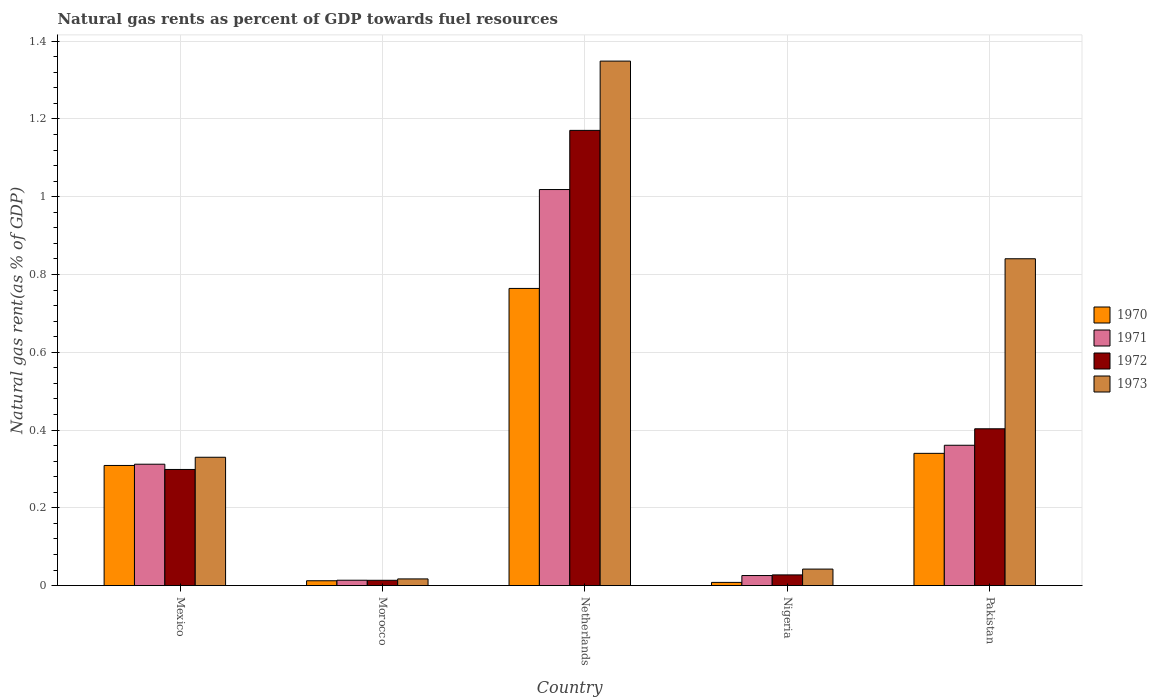How many different coloured bars are there?
Your answer should be very brief. 4. How many groups of bars are there?
Provide a short and direct response. 5. Are the number of bars per tick equal to the number of legend labels?
Make the answer very short. Yes. Are the number of bars on each tick of the X-axis equal?
Keep it short and to the point. Yes. How many bars are there on the 3rd tick from the left?
Your answer should be very brief. 4. How many bars are there on the 4th tick from the right?
Your answer should be compact. 4. What is the label of the 2nd group of bars from the left?
Make the answer very short. Morocco. In how many cases, is the number of bars for a given country not equal to the number of legend labels?
Ensure brevity in your answer.  0. What is the natural gas rent in 1970 in Morocco?
Offer a very short reply. 0.01. Across all countries, what is the maximum natural gas rent in 1971?
Keep it short and to the point. 1.02. Across all countries, what is the minimum natural gas rent in 1972?
Your answer should be very brief. 0.01. In which country was the natural gas rent in 1971 maximum?
Make the answer very short. Netherlands. In which country was the natural gas rent in 1970 minimum?
Provide a succinct answer. Nigeria. What is the total natural gas rent in 1970 in the graph?
Offer a very short reply. 1.43. What is the difference between the natural gas rent in 1973 in Morocco and that in Nigeria?
Offer a very short reply. -0.03. What is the difference between the natural gas rent in 1973 in Netherlands and the natural gas rent in 1972 in Mexico?
Ensure brevity in your answer.  1.05. What is the average natural gas rent in 1970 per country?
Your response must be concise. 0.29. What is the difference between the natural gas rent of/in 1971 and natural gas rent of/in 1972 in Nigeria?
Make the answer very short. -0. What is the ratio of the natural gas rent in 1972 in Netherlands to that in Pakistan?
Your response must be concise. 2.9. Is the difference between the natural gas rent in 1971 in Mexico and Pakistan greater than the difference between the natural gas rent in 1972 in Mexico and Pakistan?
Ensure brevity in your answer.  Yes. What is the difference between the highest and the second highest natural gas rent in 1971?
Make the answer very short. -0.66. What is the difference between the highest and the lowest natural gas rent in 1972?
Ensure brevity in your answer.  1.16. Is the sum of the natural gas rent in 1971 in Mexico and Morocco greater than the maximum natural gas rent in 1972 across all countries?
Your answer should be very brief. No. What does the 3rd bar from the right in Netherlands represents?
Provide a short and direct response. 1971. Is it the case that in every country, the sum of the natural gas rent in 1970 and natural gas rent in 1971 is greater than the natural gas rent in 1972?
Give a very brief answer. Yes. How many countries are there in the graph?
Provide a short and direct response. 5. What is the difference between two consecutive major ticks on the Y-axis?
Keep it short and to the point. 0.2. Where does the legend appear in the graph?
Provide a short and direct response. Center right. How many legend labels are there?
Your answer should be very brief. 4. How are the legend labels stacked?
Ensure brevity in your answer.  Vertical. What is the title of the graph?
Provide a short and direct response. Natural gas rents as percent of GDP towards fuel resources. Does "1973" appear as one of the legend labels in the graph?
Give a very brief answer. Yes. What is the label or title of the Y-axis?
Offer a very short reply. Natural gas rent(as % of GDP). What is the Natural gas rent(as % of GDP) of 1970 in Mexico?
Your answer should be very brief. 0.31. What is the Natural gas rent(as % of GDP) of 1971 in Mexico?
Offer a terse response. 0.31. What is the Natural gas rent(as % of GDP) in 1972 in Mexico?
Your answer should be compact. 0.3. What is the Natural gas rent(as % of GDP) of 1973 in Mexico?
Provide a succinct answer. 0.33. What is the Natural gas rent(as % of GDP) of 1970 in Morocco?
Provide a succinct answer. 0.01. What is the Natural gas rent(as % of GDP) of 1971 in Morocco?
Your answer should be compact. 0.01. What is the Natural gas rent(as % of GDP) of 1972 in Morocco?
Keep it short and to the point. 0.01. What is the Natural gas rent(as % of GDP) of 1973 in Morocco?
Keep it short and to the point. 0.02. What is the Natural gas rent(as % of GDP) in 1970 in Netherlands?
Offer a very short reply. 0.76. What is the Natural gas rent(as % of GDP) of 1971 in Netherlands?
Keep it short and to the point. 1.02. What is the Natural gas rent(as % of GDP) of 1972 in Netherlands?
Make the answer very short. 1.17. What is the Natural gas rent(as % of GDP) of 1973 in Netherlands?
Your answer should be compact. 1.35. What is the Natural gas rent(as % of GDP) of 1970 in Nigeria?
Keep it short and to the point. 0.01. What is the Natural gas rent(as % of GDP) of 1971 in Nigeria?
Ensure brevity in your answer.  0.03. What is the Natural gas rent(as % of GDP) in 1972 in Nigeria?
Give a very brief answer. 0.03. What is the Natural gas rent(as % of GDP) of 1973 in Nigeria?
Your response must be concise. 0.04. What is the Natural gas rent(as % of GDP) of 1970 in Pakistan?
Offer a terse response. 0.34. What is the Natural gas rent(as % of GDP) of 1971 in Pakistan?
Your answer should be compact. 0.36. What is the Natural gas rent(as % of GDP) in 1972 in Pakistan?
Provide a succinct answer. 0.4. What is the Natural gas rent(as % of GDP) of 1973 in Pakistan?
Keep it short and to the point. 0.84. Across all countries, what is the maximum Natural gas rent(as % of GDP) of 1970?
Ensure brevity in your answer.  0.76. Across all countries, what is the maximum Natural gas rent(as % of GDP) of 1971?
Your answer should be very brief. 1.02. Across all countries, what is the maximum Natural gas rent(as % of GDP) of 1972?
Provide a short and direct response. 1.17. Across all countries, what is the maximum Natural gas rent(as % of GDP) of 1973?
Keep it short and to the point. 1.35. Across all countries, what is the minimum Natural gas rent(as % of GDP) of 1970?
Make the answer very short. 0.01. Across all countries, what is the minimum Natural gas rent(as % of GDP) of 1971?
Your answer should be compact. 0.01. Across all countries, what is the minimum Natural gas rent(as % of GDP) in 1972?
Your answer should be very brief. 0.01. Across all countries, what is the minimum Natural gas rent(as % of GDP) of 1973?
Provide a succinct answer. 0.02. What is the total Natural gas rent(as % of GDP) in 1970 in the graph?
Provide a short and direct response. 1.43. What is the total Natural gas rent(as % of GDP) in 1971 in the graph?
Offer a very short reply. 1.73. What is the total Natural gas rent(as % of GDP) in 1972 in the graph?
Your answer should be very brief. 1.91. What is the total Natural gas rent(as % of GDP) in 1973 in the graph?
Your answer should be very brief. 2.58. What is the difference between the Natural gas rent(as % of GDP) of 1970 in Mexico and that in Morocco?
Provide a succinct answer. 0.3. What is the difference between the Natural gas rent(as % of GDP) of 1971 in Mexico and that in Morocco?
Your response must be concise. 0.3. What is the difference between the Natural gas rent(as % of GDP) of 1972 in Mexico and that in Morocco?
Your answer should be very brief. 0.28. What is the difference between the Natural gas rent(as % of GDP) of 1973 in Mexico and that in Morocco?
Your response must be concise. 0.31. What is the difference between the Natural gas rent(as % of GDP) of 1970 in Mexico and that in Netherlands?
Offer a very short reply. -0.46. What is the difference between the Natural gas rent(as % of GDP) of 1971 in Mexico and that in Netherlands?
Keep it short and to the point. -0.71. What is the difference between the Natural gas rent(as % of GDP) of 1972 in Mexico and that in Netherlands?
Give a very brief answer. -0.87. What is the difference between the Natural gas rent(as % of GDP) of 1973 in Mexico and that in Netherlands?
Provide a short and direct response. -1.02. What is the difference between the Natural gas rent(as % of GDP) of 1970 in Mexico and that in Nigeria?
Offer a very short reply. 0.3. What is the difference between the Natural gas rent(as % of GDP) in 1971 in Mexico and that in Nigeria?
Provide a succinct answer. 0.29. What is the difference between the Natural gas rent(as % of GDP) of 1972 in Mexico and that in Nigeria?
Give a very brief answer. 0.27. What is the difference between the Natural gas rent(as % of GDP) in 1973 in Mexico and that in Nigeria?
Keep it short and to the point. 0.29. What is the difference between the Natural gas rent(as % of GDP) in 1970 in Mexico and that in Pakistan?
Provide a succinct answer. -0.03. What is the difference between the Natural gas rent(as % of GDP) in 1971 in Mexico and that in Pakistan?
Provide a short and direct response. -0.05. What is the difference between the Natural gas rent(as % of GDP) of 1972 in Mexico and that in Pakistan?
Provide a succinct answer. -0.1. What is the difference between the Natural gas rent(as % of GDP) of 1973 in Mexico and that in Pakistan?
Provide a short and direct response. -0.51. What is the difference between the Natural gas rent(as % of GDP) in 1970 in Morocco and that in Netherlands?
Your answer should be very brief. -0.75. What is the difference between the Natural gas rent(as % of GDP) in 1971 in Morocco and that in Netherlands?
Keep it short and to the point. -1. What is the difference between the Natural gas rent(as % of GDP) in 1972 in Morocco and that in Netherlands?
Your response must be concise. -1.16. What is the difference between the Natural gas rent(as % of GDP) in 1973 in Morocco and that in Netherlands?
Offer a terse response. -1.33. What is the difference between the Natural gas rent(as % of GDP) of 1970 in Morocco and that in Nigeria?
Your response must be concise. 0. What is the difference between the Natural gas rent(as % of GDP) of 1971 in Morocco and that in Nigeria?
Make the answer very short. -0.01. What is the difference between the Natural gas rent(as % of GDP) of 1972 in Morocco and that in Nigeria?
Keep it short and to the point. -0.01. What is the difference between the Natural gas rent(as % of GDP) in 1973 in Morocco and that in Nigeria?
Offer a very short reply. -0.03. What is the difference between the Natural gas rent(as % of GDP) of 1970 in Morocco and that in Pakistan?
Provide a short and direct response. -0.33. What is the difference between the Natural gas rent(as % of GDP) in 1971 in Morocco and that in Pakistan?
Provide a succinct answer. -0.35. What is the difference between the Natural gas rent(as % of GDP) in 1972 in Morocco and that in Pakistan?
Keep it short and to the point. -0.39. What is the difference between the Natural gas rent(as % of GDP) in 1973 in Morocco and that in Pakistan?
Your answer should be very brief. -0.82. What is the difference between the Natural gas rent(as % of GDP) in 1970 in Netherlands and that in Nigeria?
Make the answer very short. 0.76. What is the difference between the Natural gas rent(as % of GDP) in 1971 in Netherlands and that in Nigeria?
Your answer should be compact. 0.99. What is the difference between the Natural gas rent(as % of GDP) in 1972 in Netherlands and that in Nigeria?
Ensure brevity in your answer.  1.14. What is the difference between the Natural gas rent(as % of GDP) in 1973 in Netherlands and that in Nigeria?
Give a very brief answer. 1.31. What is the difference between the Natural gas rent(as % of GDP) in 1970 in Netherlands and that in Pakistan?
Offer a terse response. 0.42. What is the difference between the Natural gas rent(as % of GDP) of 1971 in Netherlands and that in Pakistan?
Ensure brevity in your answer.  0.66. What is the difference between the Natural gas rent(as % of GDP) in 1972 in Netherlands and that in Pakistan?
Keep it short and to the point. 0.77. What is the difference between the Natural gas rent(as % of GDP) in 1973 in Netherlands and that in Pakistan?
Offer a terse response. 0.51. What is the difference between the Natural gas rent(as % of GDP) of 1970 in Nigeria and that in Pakistan?
Make the answer very short. -0.33. What is the difference between the Natural gas rent(as % of GDP) of 1971 in Nigeria and that in Pakistan?
Your answer should be compact. -0.34. What is the difference between the Natural gas rent(as % of GDP) in 1972 in Nigeria and that in Pakistan?
Give a very brief answer. -0.38. What is the difference between the Natural gas rent(as % of GDP) of 1973 in Nigeria and that in Pakistan?
Keep it short and to the point. -0.8. What is the difference between the Natural gas rent(as % of GDP) in 1970 in Mexico and the Natural gas rent(as % of GDP) in 1971 in Morocco?
Your answer should be very brief. 0.3. What is the difference between the Natural gas rent(as % of GDP) of 1970 in Mexico and the Natural gas rent(as % of GDP) of 1972 in Morocco?
Give a very brief answer. 0.3. What is the difference between the Natural gas rent(as % of GDP) of 1970 in Mexico and the Natural gas rent(as % of GDP) of 1973 in Morocco?
Provide a succinct answer. 0.29. What is the difference between the Natural gas rent(as % of GDP) in 1971 in Mexico and the Natural gas rent(as % of GDP) in 1972 in Morocco?
Your answer should be compact. 0.3. What is the difference between the Natural gas rent(as % of GDP) in 1971 in Mexico and the Natural gas rent(as % of GDP) in 1973 in Morocco?
Give a very brief answer. 0.29. What is the difference between the Natural gas rent(as % of GDP) in 1972 in Mexico and the Natural gas rent(as % of GDP) in 1973 in Morocco?
Keep it short and to the point. 0.28. What is the difference between the Natural gas rent(as % of GDP) in 1970 in Mexico and the Natural gas rent(as % of GDP) in 1971 in Netherlands?
Ensure brevity in your answer.  -0.71. What is the difference between the Natural gas rent(as % of GDP) in 1970 in Mexico and the Natural gas rent(as % of GDP) in 1972 in Netherlands?
Offer a terse response. -0.86. What is the difference between the Natural gas rent(as % of GDP) in 1970 in Mexico and the Natural gas rent(as % of GDP) in 1973 in Netherlands?
Ensure brevity in your answer.  -1.04. What is the difference between the Natural gas rent(as % of GDP) in 1971 in Mexico and the Natural gas rent(as % of GDP) in 1972 in Netherlands?
Make the answer very short. -0.86. What is the difference between the Natural gas rent(as % of GDP) of 1971 in Mexico and the Natural gas rent(as % of GDP) of 1973 in Netherlands?
Provide a short and direct response. -1.04. What is the difference between the Natural gas rent(as % of GDP) of 1972 in Mexico and the Natural gas rent(as % of GDP) of 1973 in Netherlands?
Give a very brief answer. -1.05. What is the difference between the Natural gas rent(as % of GDP) in 1970 in Mexico and the Natural gas rent(as % of GDP) in 1971 in Nigeria?
Provide a short and direct response. 0.28. What is the difference between the Natural gas rent(as % of GDP) in 1970 in Mexico and the Natural gas rent(as % of GDP) in 1972 in Nigeria?
Keep it short and to the point. 0.28. What is the difference between the Natural gas rent(as % of GDP) in 1970 in Mexico and the Natural gas rent(as % of GDP) in 1973 in Nigeria?
Your answer should be very brief. 0.27. What is the difference between the Natural gas rent(as % of GDP) of 1971 in Mexico and the Natural gas rent(as % of GDP) of 1972 in Nigeria?
Your answer should be compact. 0.28. What is the difference between the Natural gas rent(as % of GDP) of 1971 in Mexico and the Natural gas rent(as % of GDP) of 1973 in Nigeria?
Offer a very short reply. 0.27. What is the difference between the Natural gas rent(as % of GDP) in 1972 in Mexico and the Natural gas rent(as % of GDP) in 1973 in Nigeria?
Your answer should be compact. 0.26. What is the difference between the Natural gas rent(as % of GDP) of 1970 in Mexico and the Natural gas rent(as % of GDP) of 1971 in Pakistan?
Provide a succinct answer. -0.05. What is the difference between the Natural gas rent(as % of GDP) in 1970 in Mexico and the Natural gas rent(as % of GDP) in 1972 in Pakistan?
Your answer should be very brief. -0.09. What is the difference between the Natural gas rent(as % of GDP) of 1970 in Mexico and the Natural gas rent(as % of GDP) of 1973 in Pakistan?
Offer a terse response. -0.53. What is the difference between the Natural gas rent(as % of GDP) in 1971 in Mexico and the Natural gas rent(as % of GDP) in 1972 in Pakistan?
Make the answer very short. -0.09. What is the difference between the Natural gas rent(as % of GDP) of 1971 in Mexico and the Natural gas rent(as % of GDP) of 1973 in Pakistan?
Ensure brevity in your answer.  -0.53. What is the difference between the Natural gas rent(as % of GDP) of 1972 in Mexico and the Natural gas rent(as % of GDP) of 1973 in Pakistan?
Offer a terse response. -0.54. What is the difference between the Natural gas rent(as % of GDP) in 1970 in Morocco and the Natural gas rent(as % of GDP) in 1971 in Netherlands?
Your answer should be compact. -1.01. What is the difference between the Natural gas rent(as % of GDP) of 1970 in Morocco and the Natural gas rent(as % of GDP) of 1972 in Netherlands?
Your response must be concise. -1.16. What is the difference between the Natural gas rent(as % of GDP) in 1970 in Morocco and the Natural gas rent(as % of GDP) in 1973 in Netherlands?
Your answer should be compact. -1.34. What is the difference between the Natural gas rent(as % of GDP) of 1971 in Morocco and the Natural gas rent(as % of GDP) of 1972 in Netherlands?
Provide a short and direct response. -1.16. What is the difference between the Natural gas rent(as % of GDP) of 1971 in Morocco and the Natural gas rent(as % of GDP) of 1973 in Netherlands?
Your answer should be very brief. -1.33. What is the difference between the Natural gas rent(as % of GDP) in 1972 in Morocco and the Natural gas rent(as % of GDP) in 1973 in Netherlands?
Keep it short and to the point. -1.34. What is the difference between the Natural gas rent(as % of GDP) of 1970 in Morocco and the Natural gas rent(as % of GDP) of 1971 in Nigeria?
Your response must be concise. -0.01. What is the difference between the Natural gas rent(as % of GDP) in 1970 in Morocco and the Natural gas rent(as % of GDP) in 1972 in Nigeria?
Provide a short and direct response. -0.02. What is the difference between the Natural gas rent(as % of GDP) of 1970 in Morocco and the Natural gas rent(as % of GDP) of 1973 in Nigeria?
Ensure brevity in your answer.  -0.03. What is the difference between the Natural gas rent(as % of GDP) of 1971 in Morocco and the Natural gas rent(as % of GDP) of 1972 in Nigeria?
Give a very brief answer. -0.01. What is the difference between the Natural gas rent(as % of GDP) of 1971 in Morocco and the Natural gas rent(as % of GDP) of 1973 in Nigeria?
Offer a terse response. -0.03. What is the difference between the Natural gas rent(as % of GDP) in 1972 in Morocco and the Natural gas rent(as % of GDP) in 1973 in Nigeria?
Your response must be concise. -0.03. What is the difference between the Natural gas rent(as % of GDP) in 1970 in Morocco and the Natural gas rent(as % of GDP) in 1971 in Pakistan?
Give a very brief answer. -0.35. What is the difference between the Natural gas rent(as % of GDP) of 1970 in Morocco and the Natural gas rent(as % of GDP) of 1972 in Pakistan?
Offer a terse response. -0.39. What is the difference between the Natural gas rent(as % of GDP) in 1970 in Morocco and the Natural gas rent(as % of GDP) in 1973 in Pakistan?
Offer a terse response. -0.83. What is the difference between the Natural gas rent(as % of GDP) in 1971 in Morocco and the Natural gas rent(as % of GDP) in 1972 in Pakistan?
Your answer should be very brief. -0.39. What is the difference between the Natural gas rent(as % of GDP) of 1971 in Morocco and the Natural gas rent(as % of GDP) of 1973 in Pakistan?
Offer a very short reply. -0.83. What is the difference between the Natural gas rent(as % of GDP) of 1972 in Morocco and the Natural gas rent(as % of GDP) of 1973 in Pakistan?
Give a very brief answer. -0.83. What is the difference between the Natural gas rent(as % of GDP) in 1970 in Netherlands and the Natural gas rent(as % of GDP) in 1971 in Nigeria?
Give a very brief answer. 0.74. What is the difference between the Natural gas rent(as % of GDP) in 1970 in Netherlands and the Natural gas rent(as % of GDP) in 1972 in Nigeria?
Your response must be concise. 0.74. What is the difference between the Natural gas rent(as % of GDP) in 1970 in Netherlands and the Natural gas rent(as % of GDP) in 1973 in Nigeria?
Your response must be concise. 0.72. What is the difference between the Natural gas rent(as % of GDP) in 1971 in Netherlands and the Natural gas rent(as % of GDP) in 1972 in Nigeria?
Your response must be concise. 0.99. What is the difference between the Natural gas rent(as % of GDP) in 1971 in Netherlands and the Natural gas rent(as % of GDP) in 1973 in Nigeria?
Provide a short and direct response. 0.98. What is the difference between the Natural gas rent(as % of GDP) of 1972 in Netherlands and the Natural gas rent(as % of GDP) of 1973 in Nigeria?
Your response must be concise. 1.13. What is the difference between the Natural gas rent(as % of GDP) in 1970 in Netherlands and the Natural gas rent(as % of GDP) in 1971 in Pakistan?
Your answer should be very brief. 0.4. What is the difference between the Natural gas rent(as % of GDP) of 1970 in Netherlands and the Natural gas rent(as % of GDP) of 1972 in Pakistan?
Provide a short and direct response. 0.36. What is the difference between the Natural gas rent(as % of GDP) in 1970 in Netherlands and the Natural gas rent(as % of GDP) in 1973 in Pakistan?
Offer a very short reply. -0.08. What is the difference between the Natural gas rent(as % of GDP) of 1971 in Netherlands and the Natural gas rent(as % of GDP) of 1972 in Pakistan?
Offer a terse response. 0.62. What is the difference between the Natural gas rent(as % of GDP) in 1971 in Netherlands and the Natural gas rent(as % of GDP) in 1973 in Pakistan?
Offer a terse response. 0.18. What is the difference between the Natural gas rent(as % of GDP) in 1972 in Netherlands and the Natural gas rent(as % of GDP) in 1973 in Pakistan?
Make the answer very short. 0.33. What is the difference between the Natural gas rent(as % of GDP) of 1970 in Nigeria and the Natural gas rent(as % of GDP) of 1971 in Pakistan?
Give a very brief answer. -0.35. What is the difference between the Natural gas rent(as % of GDP) in 1970 in Nigeria and the Natural gas rent(as % of GDP) in 1972 in Pakistan?
Your response must be concise. -0.4. What is the difference between the Natural gas rent(as % of GDP) in 1970 in Nigeria and the Natural gas rent(as % of GDP) in 1973 in Pakistan?
Offer a very short reply. -0.83. What is the difference between the Natural gas rent(as % of GDP) of 1971 in Nigeria and the Natural gas rent(as % of GDP) of 1972 in Pakistan?
Keep it short and to the point. -0.38. What is the difference between the Natural gas rent(as % of GDP) of 1971 in Nigeria and the Natural gas rent(as % of GDP) of 1973 in Pakistan?
Provide a succinct answer. -0.81. What is the difference between the Natural gas rent(as % of GDP) of 1972 in Nigeria and the Natural gas rent(as % of GDP) of 1973 in Pakistan?
Keep it short and to the point. -0.81. What is the average Natural gas rent(as % of GDP) of 1970 per country?
Provide a short and direct response. 0.29. What is the average Natural gas rent(as % of GDP) of 1971 per country?
Make the answer very short. 0.35. What is the average Natural gas rent(as % of GDP) in 1972 per country?
Provide a succinct answer. 0.38. What is the average Natural gas rent(as % of GDP) in 1973 per country?
Give a very brief answer. 0.52. What is the difference between the Natural gas rent(as % of GDP) in 1970 and Natural gas rent(as % of GDP) in 1971 in Mexico?
Your answer should be very brief. -0. What is the difference between the Natural gas rent(as % of GDP) in 1970 and Natural gas rent(as % of GDP) in 1972 in Mexico?
Provide a succinct answer. 0.01. What is the difference between the Natural gas rent(as % of GDP) of 1970 and Natural gas rent(as % of GDP) of 1973 in Mexico?
Give a very brief answer. -0.02. What is the difference between the Natural gas rent(as % of GDP) in 1971 and Natural gas rent(as % of GDP) in 1972 in Mexico?
Your answer should be compact. 0.01. What is the difference between the Natural gas rent(as % of GDP) of 1971 and Natural gas rent(as % of GDP) of 1973 in Mexico?
Provide a succinct answer. -0.02. What is the difference between the Natural gas rent(as % of GDP) in 1972 and Natural gas rent(as % of GDP) in 1973 in Mexico?
Offer a very short reply. -0.03. What is the difference between the Natural gas rent(as % of GDP) in 1970 and Natural gas rent(as % of GDP) in 1971 in Morocco?
Your answer should be very brief. -0. What is the difference between the Natural gas rent(as % of GDP) in 1970 and Natural gas rent(as % of GDP) in 1972 in Morocco?
Provide a short and direct response. -0. What is the difference between the Natural gas rent(as % of GDP) of 1970 and Natural gas rent(as % of GDP) of 1973 in Morocco?
Your response must be concise. -0. What is the difference between the Natural gas rent(as % of GDP) of 1971 and Natural gas rent(as % of GDP) of 1973 in Morocco?
Your answer should be very brief. -0. What is the difference between the Natural gas rent(as % of GDP) in 1972 and Natural gas rent(as % of GDP) in 1973 in Morocco?
Offer a terse response. -0. What is the difference between the Natural gas rent(as % of GDP) in 1970 and Natural gas rent(as % of GDP) in 1971 in Netherlands?
Your response must be concise. -0.25. What is the difference between the Natural gas rent(as % of GDP) in 1970 and Natural gas rent(as % of GDP) in 1972 in Netherlands?
Make the answer very short. -0.41. What is the difference between the Natural gas rent(as % of GDP) of 1970 and Natural gas rent(as % of GDP) of 1973 in Netherlands?
Keep it short and to the point. -0.58. What is the difference between the Natural gas rent(as % of GDP) in 1971 and Natural gas rent(as % of GDP) in 1972 in Netherlands?
Offer a terse response. -0.15. What is the difference between the Natural gas rent(as % of GDP) of 1971 and Natural gas rent(as % of GDP) of 1973 in Netherlands?
Offer a terse response. -0.33. What is the difference between the Natural gas rent(as % of GDP) in 1972 and Natural gas rent(as % of GDP) in 1973 in Netherlands?
Make the answer very short. -0.18. What is the difference between the Natural gas rent(as % of GDP) of 1970 and Natural gas rent(as % of GDP) of 1971 in Nigeria?
Keep it short and to the point. -0.02. What is the difference between the Natural gas rent(as % of GDP) in 1970 and Natural gas rent(as % of GDP) in 1972 in Nigeria?
Provide a short and direct response. -0.02. What is the difference between the Natural gas rent(as % of GDP) of 1970 and Natural gas rent(as % of GDP) of 1973 in Nigeria?
Offer a terse response. -0.03. What is the difference between the Natural gas rent(as % of GDP) in 1971 and Natural gas rent(as % of GDP) in 1972 in Nigeria?
Give a very brief answer. -0. What is the difference between the Natural gas rent(as % of GDP) in 1971 and Natural gas rent(as % of GDP) in 1973 in Nigeria?
Keep it short and to the point. -0.02. What is the difference between the Natural gas rent(as % of GDP) of 1972 and Natural gas rent(as % of GDP) of 1973 in Nigeria?
Provide a short and direct response. -0.01. What is the difference between the Natural gas rent(as % of GDP) of 1970 and Natural gas rent(as % of GDP) of 1971 in Pakistan?
Offer a very short reply. -0.02. What is the difference between the Natural gas rent(as % of GDP) of 1970 and Natural gas rent(as % of GDP) of 1972 in Pakistan?
Keep it short and to the point. -0.06. What is the difference between the Natural gas rent(as % of GDP) in 1970 and Natural gas rent(as % of GDP) in 1973 in Pakistan?
Ensure brevity in your answer.  -0.5. What is the difference between the Natural gas rent(as % of GDP) of 1971 and Natural gas rent(as % of GDP) of 1972 in Pakistan?
Offer a terse response. -0.04. What is the difference between the Natural gas rent(as % of GDP) in 1971 and Natural gas rent(as % of GDP) in 1973 in Pakistan?
Make the answer very short. -0.48. What is the difference between the Natural gas rent(as % of GDP) of 1972 and Natural gas rent(as % of GDP) of 1973 in Pakistan?
Offer a terse response. -0.44. What is the ratio of the Natural gas rent(as % of GDP) of 1970 in Mexico to that in Morocco?
Offer a terse response. 25. What is the ratio of the Natural gas rent(as % of GDP) of 1971 in Mexico to that in Morocco?
Offer a terse response. 22.74. What is the ratio of the Natural gas rent(as % of GDP) of 1972 in Mexico to that in Morocco?
Ensure brevity in your answer.  22.04. What is the ratio of the Natural gas rent(as % of GDP) of 1973 in Mexico to that in Morocco?
Provide a short and direct response. 19.3. What is the ratio of the Natural gas rent(as % of GDP) of 1970 in Mexico to that in Netherlands?
Provide a short and direct response. 0.4. What is the ratio of the Natural gas rent(as % of GDP) in 1971 in Mexico to that in Netherlands?
Give a very brief answer. 0.31. What is the ratio of the Natural gas rent(as % of GDP) in 1972 in Mexico to that in Netherlands?
Make the answer very short. 0.26. What is the ratio of the Natural gas rent(as % of GDP) of 1973 in Mexico to that in Netherlands?
Your answer should be compact. 0.24. What is the ratio of the Natural gas rent(as % of GDP) in 1970 in Mexico to that in Nigeria?
Your answer should be compact. 37.97. What is the ratio of the Natural gas rent(as % of GDP) of 1971 in Mexico to that in Nigeria?
Provide a short and direct response. 12.1. What is the ratio of the Natural gas rent(as % of GDP) of 1972 in Mexico to that in Nigeria?
Offer a very short reply. 10.89. What is the ratio of the Natural gas rent(as % of GDP) of 1973 in Mexico to that in Nigeria?
Keep it short and to the point. 7.79. What is the ratio of the Natural gas rent(as % of GDP) in 1970 in Mexico to that in Pakistan?
Your response must be concise. 0.91. What is the ratio of the Natural gas rent(as % of GDP) in 1971 in Mexico to that in Pakistan?
Your response must be concise. 0.86. What is the ratio of the Natural gas rent(as % of GDP) of 1972 in Mexico to that in Pakistan?
Your answer should be compact. 0.74. What is the ratio of the Natural gas rent(as % of GDP) of 1973 in Mexico to that in Pakistan?
Offer a terse response. 0.39. What is the ratio of the Natural gas rent(as % of GDP) in 1970 in Morocco to that in Netherlands?
Your response must be concise. 0.02. What is the ratio of the Natural gas rent(as % of GDP) of 1971 in Morocco to that in Netherlands?
Keep it short and to the point. 0.01. What is the ratio of the Natural gas rent(as % of GDP) of 1972 in Morocco to that in Netherlands?
Offer a very short reply. 0.01. What is the ratio of the Natural gas rent(as % of GDP) in 1973 in Morocco to that in Netherlands?
Your response must be concise. 0.01. What is the ratio of the Natural gas rent(as % of GDP) of 1970 in Morocco to that in Nigeria?
Offer a terse response. 1.52. What is the ratio of the Natural gas rent(as % of GDP) of 1971 in Morocco to that in Nigeria?
Provide a succinct answer. 0.53. What is the ratio of the Natural gas rent(as % of GDP) in 1972 in Morocco to that in Nigeria?
Your answer should be compact. 0.49. What is the ratio of the Natural gas rent(as % of GDP) of 1973 in Morocco to that in Nigeria?
Your answer should be compact. 0.4. What is the ratio of the Natural gas rent(as % of GDP) of 1970 in Morocco to that in Pakistan?
Keep it short and to the point. 0.04. What is the ratio of the Natural gas rent(as % of GDP) in 1971 in Morocco to that in Pakistan?
Make the answer very short. 0.04. What is the ratio of the Natural gas rent(as % of GDP) in 1972 in Morocco to that in Pakistan?
Ensure brevity in your answer.  0.03. What is the ratio of the Natural gas rent(as % of GDP) in 1973 in Morocco to that in Pakistan?
Ensure brevity in your answer.  0.02. What is the ratio of the Natural gas rent(as % of GDP) of 1970 in Netherlands to that in Nigeria?
Ensure brevity in your answer.  93.94. What is the ratio of the Natural gas rent(as % of GDP) of 1971 in Netherlands to that in Nigeria?
Keep it short and to the point. 39.48. What is the ratio of the Natural gas rent(as % of GDP) of 1972 in Netherlands to that in Nigeria?
Ensure brevity in your answer.  42.7. What is the ratio of the Natural gas rent(as % of GDP) of 1973 in Netherlands to that in Nigeria?
Ensure brevity in your answer.  31.84. What is the ratio of the Natural gas rent(as % of GDP) of 1970 in Netherlands to that in Pakistan?
Your answer should be very brief. 2.25. What is the ratio of the Natural gas rent(as % of GDP) in 1971 in Netherlands to that in Pakistan?
Provide a succinct answer. 2.82. What is the ratio of the Natural gas rent(as % of GDP) of 1972 in Netherlands to that in Pakistan?
Keep it short and to the point. 2.9. What is the ratio of the Natural gas rent(as % of GDP) of 1973 in Netherlands to that in Pakistan?
Offer a very short reply. 1.6. What is the ratio of the Natural gas rent(as % of GDP) of 1970 in Nigeria to that in Pakistan?
Your answer should be very brief. 0.02. What is the ratio of the Natural gas rent(as % of GDP) in 1971 in Nigeria to that in Pakistan?
Ensure brevity in your answer.  0.07. What is the ratio of the Natural gas rent(as % of GDP) in 1972 in Nigeria to that in Pakistan?
Your response must be concise. 0.07. What is the ratio of the Natural gas rent(as % of GDP) in 1973 in Nigeria to that in Pakistan?
Ensure brevity in your answer.  0.05. What is the difference between the highest and the second highest Natural gas rent(as % of GDP) of 1970?
Provide a short and direct response. 0.42. What is the difference between the highest and the second highest Natural gas rent(as % of GDP) of 1971?
Your answer should be compact. 0.66. What is the difference between the highest and the second highest Natural gas rent(as % of GDP) in 1972?
Keep it short and to the point. 0.77. What is the difference between the highest and the second highest Natural gas rent(as % of GDP) in 1973?
Offer a terse response. 0.51. What is the difference between the highest and the lowest Natural gas rent(as % of GDP) in 1970?
Your response must be concise. 0.76. What is the difference between the highest and the lowest Natural gas rent(as % of GDP) in 1972?
Provide a short and direct response. 1.16. What is the difference between the highest and the lowest Natural gas rent(as % of GDP) of 1973?
Offer a terse response. 1.33. 